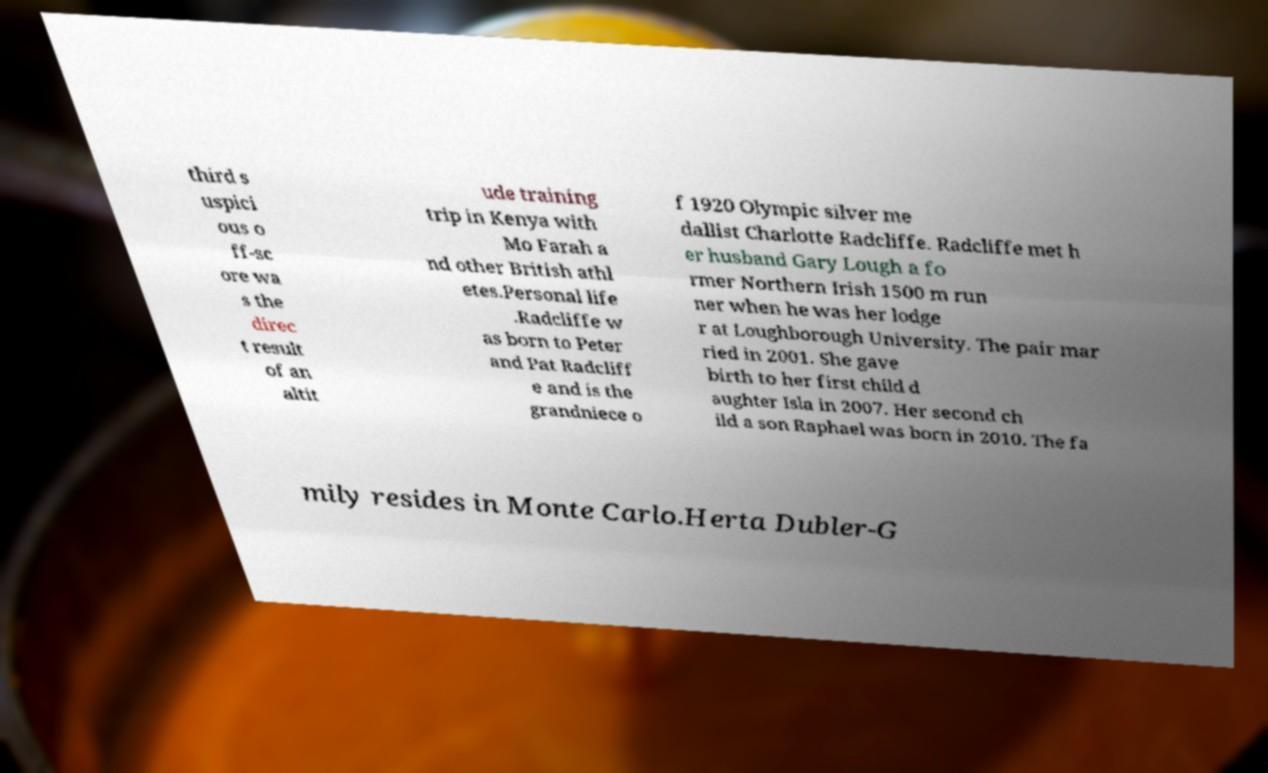Could you assist in decoding the text presented in this image and type it out clearly? third s uspici ous o ff-sc ore wa s the direc t result of an altit ude training trip in Kenya with Mo Farah a nd other British athl etes.Personal life .Radcliffe w as born to Peter and Pat Radcliff e and is the grandniece o f 1920 Olympic silver me dallist Charlotte Radcliffe. Radcliffe met h er husband Gary Lough a fo rmer Northern Irish 1500 m run ner when he was her lodge r at Loughborough University. The pair mar ried in 2001. She gave birth to her first child d aughter Isla in 2007. Her second ch ild a son Raphael was born in 2010. The fa mily resides in Monte Carlo.Herta Dubler-G 